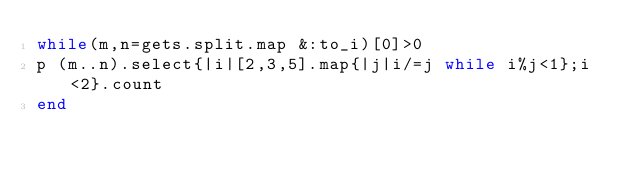<code> <loc_0><loc_0><loc_500><loc_500><_Ruby_>while(m,n=gets.split.map &:to_i)[0]>0
p (m..n).select{|i|[2,3,5].map{|j|i/=j while i%j<1};i<2}.count
end</code> 